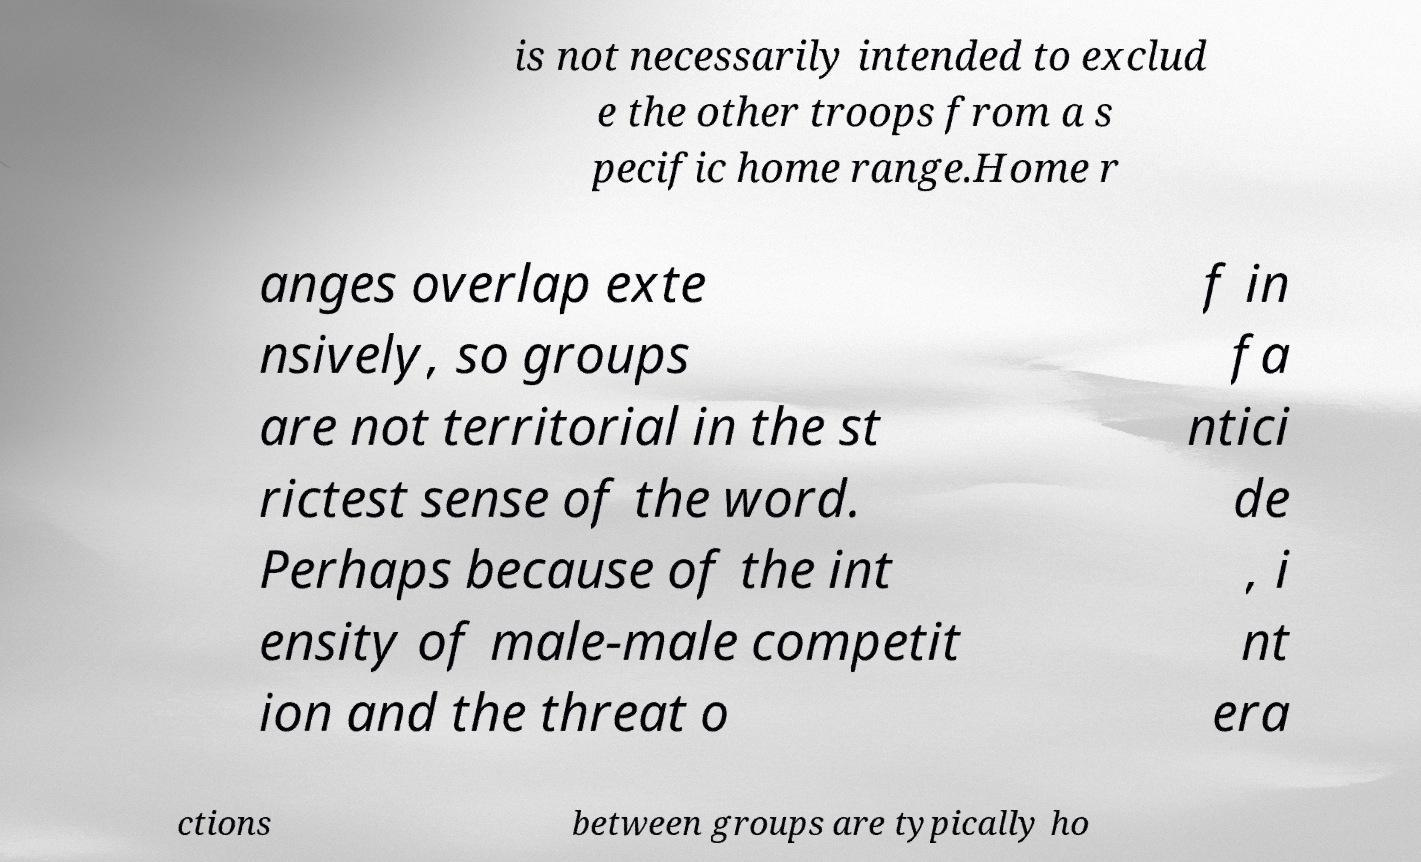I need the written content from this picture converted into text. Can you do that? is not necessarily intended to exclud e the other troops from a s pecific home range.Home r anges overlap exte nsively, so groups are not territorial in the st rictest sense of the word. Perhaps because of the int ensity of male-male competit ion and the threat o f in fa ntici de , i nt era ctions between groups are typically ho 